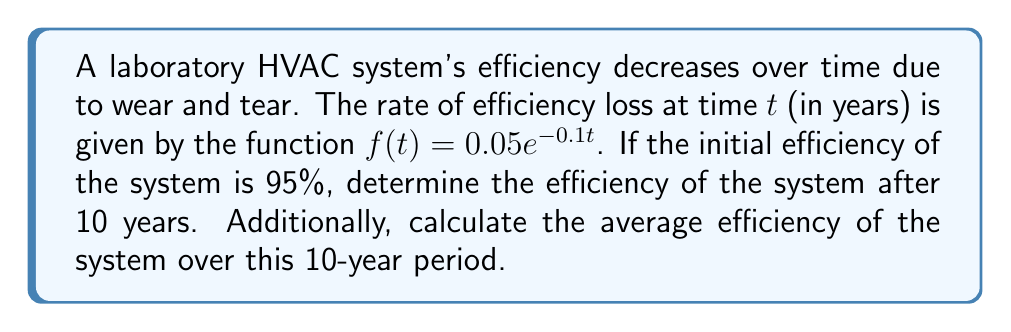Provide a solution to this math problem. To solve this problem, we need to use integral calculus and differential equations. Let's break it down step by step:

1) Let $E(t)$ represent the efficiency of the system at time $t$. We know that:

   $$\frac{dE}{dt} = -f(t) = -0.05e^{-0.1t}$$

2) To find $E(t)$, we need to integrate both sides:

   $$\int \frac{dE}{dt} dt = \int -0.05e^{-0.1t} dt$$

   $$E(t) = 0.5e^{-0.1t} + C$$

3) We can find $C$ using the initial condition: $E(0) = 0.95$

   $$0.95 = 0.5e^{-0.1(0)} + C$$
   $$0.95 = 0.5 + C$$
   $$C = 0.45$$

4) Therefore, the efficiency function is:

   $$E(t) = 0.5e^{-0.1t} + 0.45$$

5) To find the efficiency after 10 years, we calculate $E(10)$:

   $$E(10) = 0.5e^{-0.1(10)} + 0.45 = 0.5e^{-1} + 0.45 \approx 0.6341$$

6) To find the average efficiency over 10 years, we need to calculate:

   $$\frac{1}{10}\int_0^{10} E(t) dt$$

   $$= \frac{1}{10}\int_0^{10} (0.5e^{-0.1t} + 0.45) dt$$
   $$= \frac{1}{10}[-5e^{-0.1t} + 0.45t]_0^{10}$$
   $$= \frac{1}{10}[(-5e^{-1} + 4.5) - (-5 + 0)]$$
   $$= \frac{1}{10}[-5e^{-1} + 9.5]$$
   $$\approx 0.8160$$
Answer: The efficiency of the HVAC system after 10 years is approximately 63.41%. The average efficiency over the 10-year period is approximately 81.60%. 